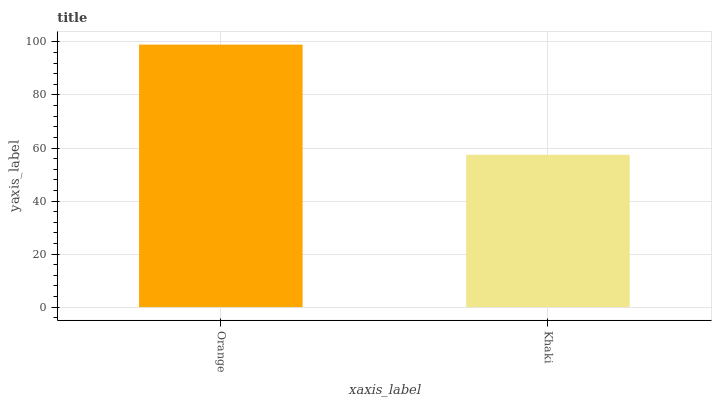Is Khaki the maximum?
Answer yes or no. No. Is Orange greater than Khaki?
Answer yes or no. Yes. Is Khaki less than Orange?
Answer yes or no. Yes. Is Khaki greater than Orange?
Answer yes or no. No. Is Orange less than Khaki?
Answer yes or no. No. Is Orange the high median?
Answer yes or no. Yes. Is Khaki the low median?
Answer yes or no. Yes. Is Khaki the high median?
Answer yes or no. No. Is Orange the low median?
Answer yes or no. No. 